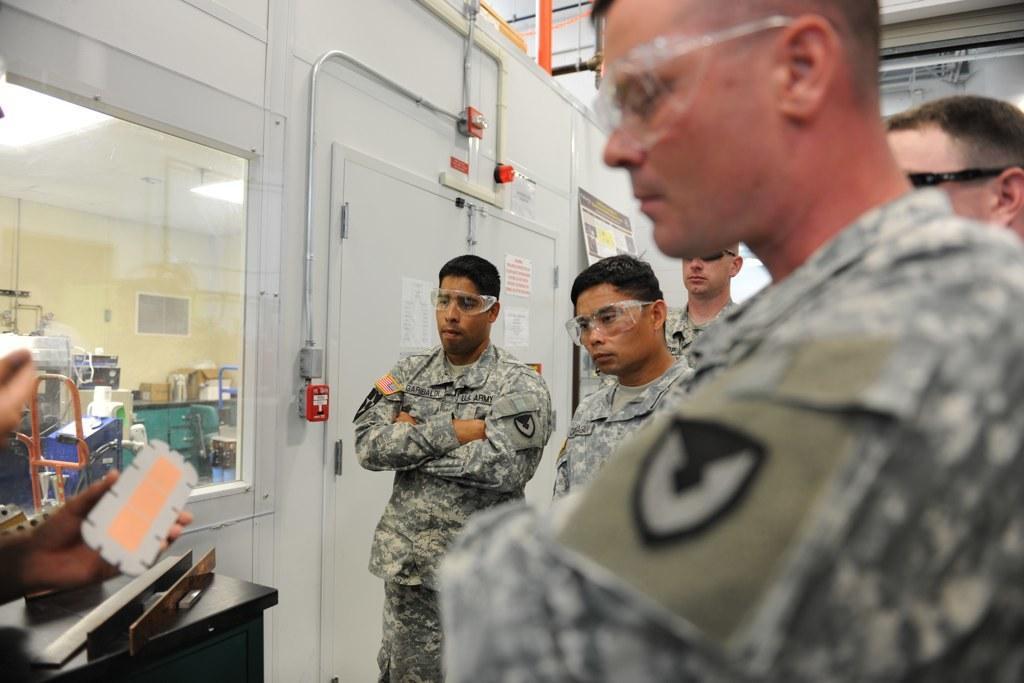Could you give a brief overview of what you see in this image? In this image there are group of persons standing. On the left side there is a white colour door and there is a window. Behind the window there are objects which are white and blue in colour and there is a table which is green in colour. On the left side the hand of the person is visible holding an object which is white and pink in colour and there is a black colour stand. 